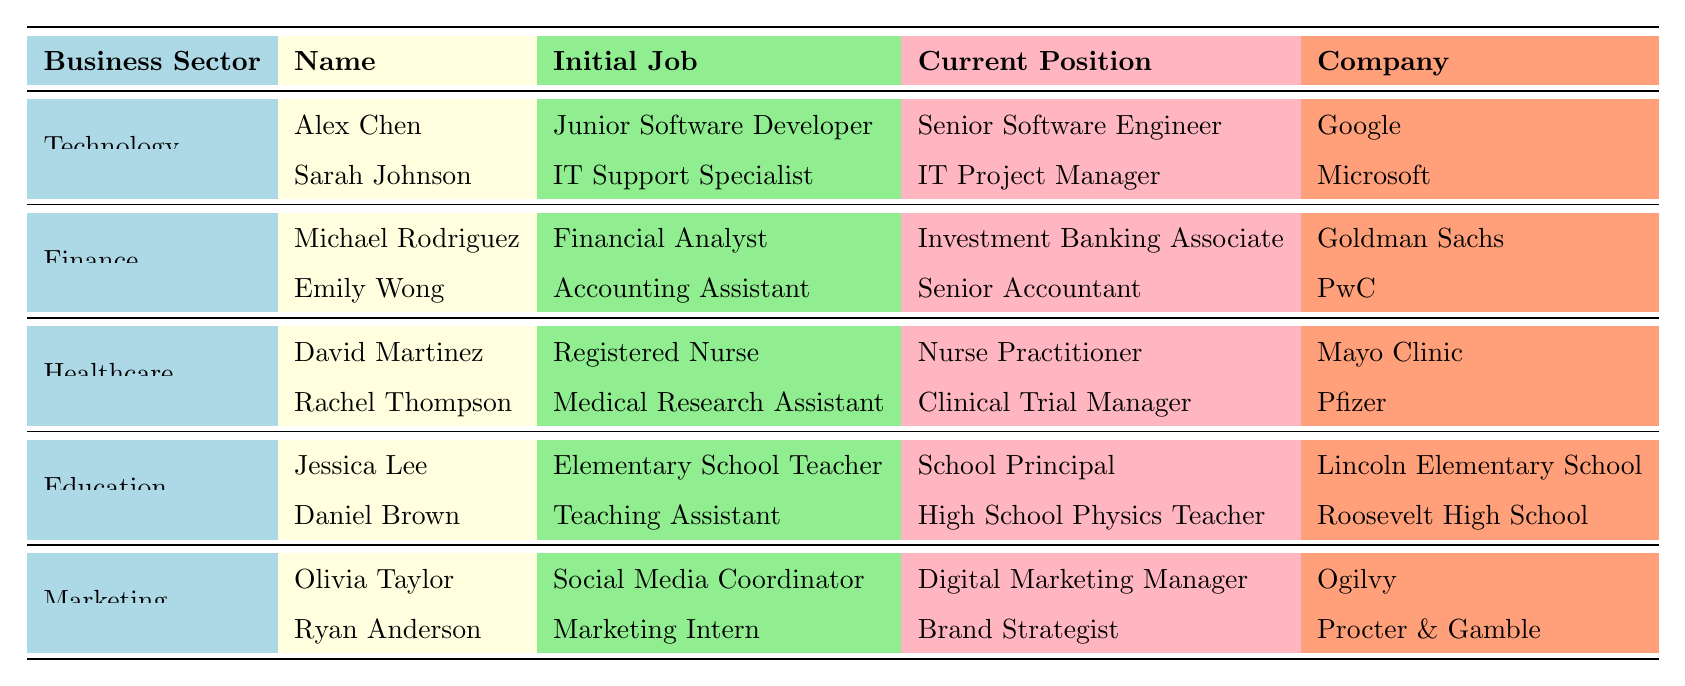What is the current position of Alex Chen? The table indicates that Alex Chen's current position is listed under the Technology sector, and he is a Senior Software Engineer.
Answer: Senior Software Engineer Who works as a Digital Marketing Manager? The table shows that Olivia Taylor holds the position of Digital Marketing Manager in the Marketing sector.
Answer: Olivia Taylor How many years since graduation does Rachel Thompson have? According to the table, Rachel Thompson has 8 years since graduation, as indicated in the Healthcare sector details.
Answer: 8 years Is Emily Wong working in the same company as David Martinez? The table indicates that Emily Wong works at PwC while David Martinez is employed at Mayo Clinic, which means they are in different companies.
Answer: No Which two graduates from the Education sector have changed their initial jobs to higher positions? From the Education sector, Jessica Lee started as an Elementary School Teacher and became a School Principal, while Daniel Brown advanced from Teaching Assistant to High School Physics Teacher.
Answer: Jessica Lee and Daniel Brown What is the initial job of Ryan Anderson? The table specifies that Ryan Anderson's initial job was as a Marketing Intern in the Marketing sector.
Answer: Marketing Intern Which business sector has the most graduates listed? The table lists 2 graduates per business sector, indicating that no sector has more graduates than others.
Answer: All sectors have the same number If we list all current positions, how many are in management roles? In the table, Sarah Johnson, Michael Rodriguez, Emily Wong, Rachel Thompson, Jessica Lee, and Olivia Taylor currently hold management roles. Sum them up gives us a total of 6.
Answer: 6 Which graduate has the longest job title? By reviewing the current job titles, "Investment Banking Associate" for Michael Rodriguez is the longest. Since it has 30 characters, it is the longest title.
Answer: Michael Rodriguez Was any graduate in the Technology sector initially hired as an accountant? The table shows that there are no graduates in the Technology sector who started as accountants; only roles like Junior Software Developer and IT Support Specialist are listed.
Answer: No 